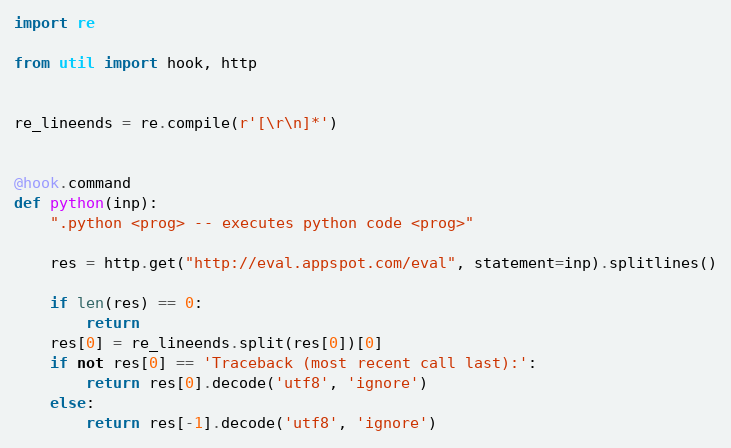<code> <loc_0><loc_0><loc_500><loc_500><_Python_>import re

from util import hook, http


re_lineends = re.compile(r'[\r\n]*')


@hook.command
def python(inp):
    ".python <prog> -- executes python code <prog>"

    res = http.get("http://eval.appspot.com/eval", statement=inp).splitlines()

    if len(res) == 0:
        return
    res[0] = re_lineends.split(res[0])[0]
    if not res[0] == 'Traceback (most recent call last):':
        return res[0].decode('utf8', 'ignore')
    else:
        return res[-1].decode('utf8', 'ignore')
</code> 